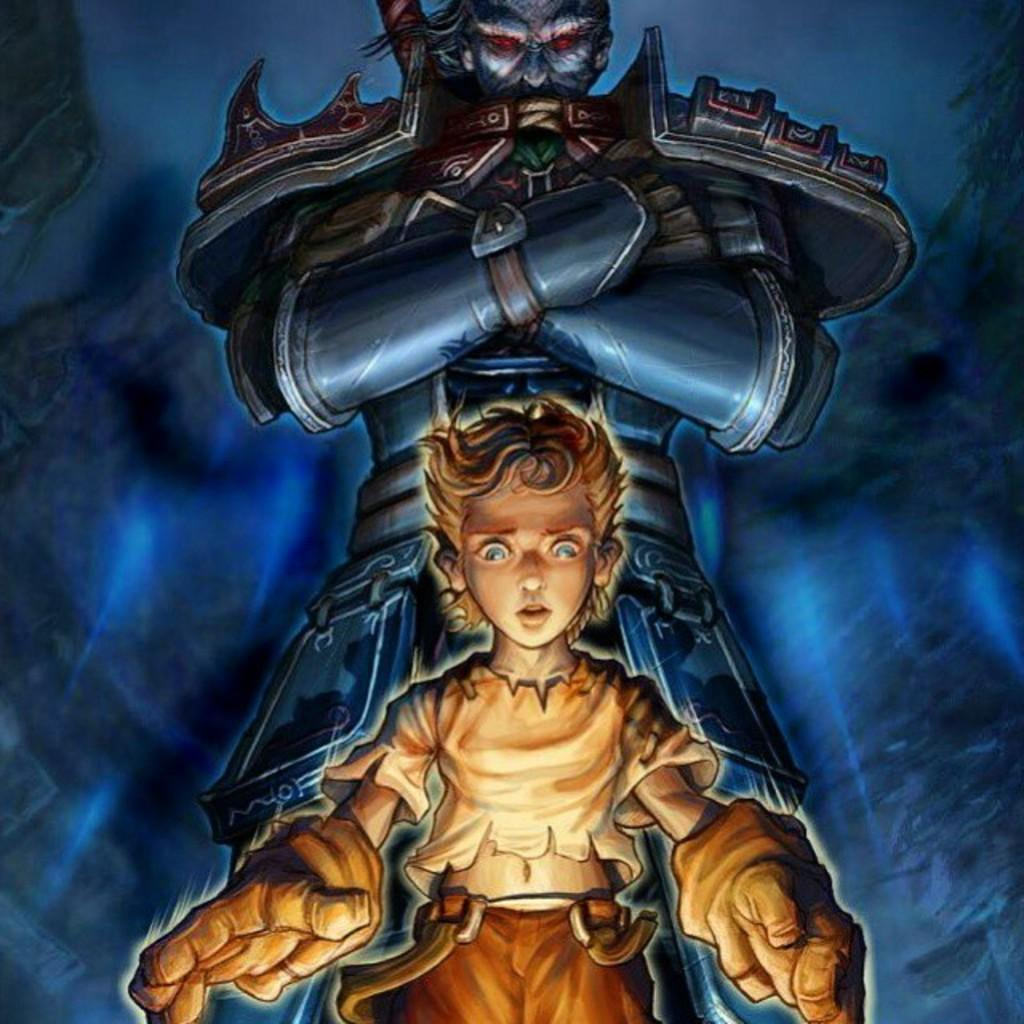What is the main subject of the picture? The main subject of the picture is an animation of a boy. What color is the animation of the boy? The animation of the boy is in brown color. Are there any other characters in the picture? Yes, there is an animation of a monster in the picture. What is the color of the background in the image? The background of the image is in blue color. What type of club does the boy use to hit the monster in the image? There is no club present in the image, nor is the boy hitting the monster. The image is an animation, and the boy and monster are not interacting in a physical manner. 